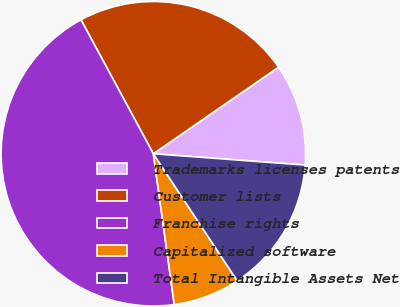Convert chart. <chart><loc_0><loc_0><loc_500><loc_500><pie_chart><fcel>Trademarks licenses patents<fcel>Customer lists<fcel>Franchise rights<fcel>Capitalized software<fcel>Total Intangible Assets Net<nl><fcel>10.81%<fcel>23.26%<fcel>44.31%<fcel>7.09%<fcel>14.53%<nl></chart> 